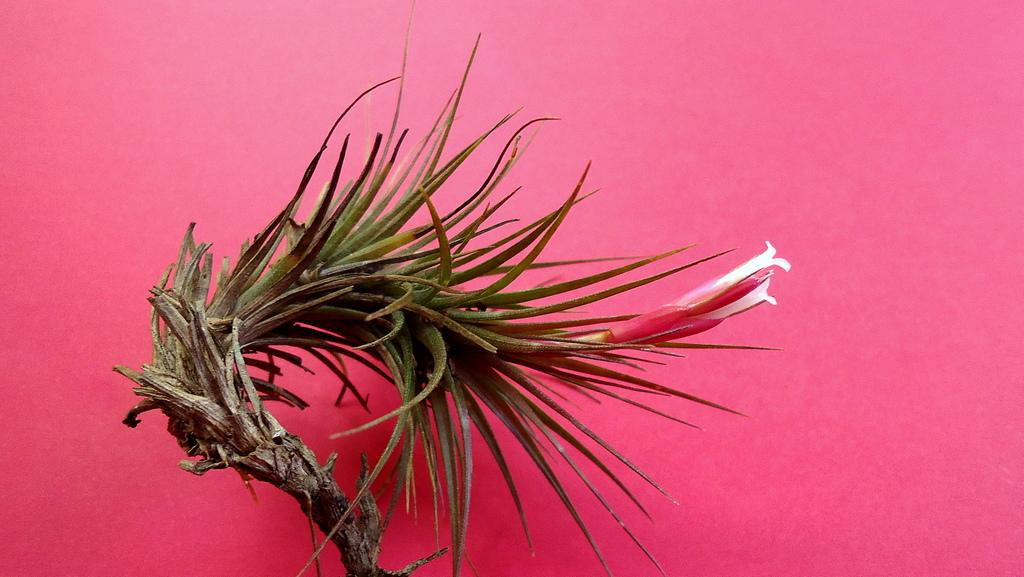What color is the surface in the image? The surface in the image is pink. What objects can be seen on the pink surface? There is a brown object and a white and red object on the pink surface. How does the pipe shake in the image? There is no pipe present in the image, so it cannot shake. 